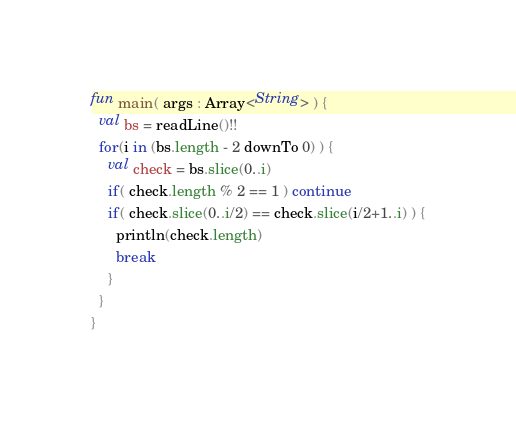<code> <loc_0><loc_0><loc_500><loc_500><_Kotlin_>fun main( args : Array<String> ) {
  val bs = readLine()!!
  for(i in (bs.length - 2 downTo 0) ) {
    val check = bs.slice(0..i)
    if( check.length % 2 == 1 ) continue
    if( check.slice(0..i/2) == check.slice(i/2+1..i) ) {
      println(check.length)
      break
    }
  }
}</code> 